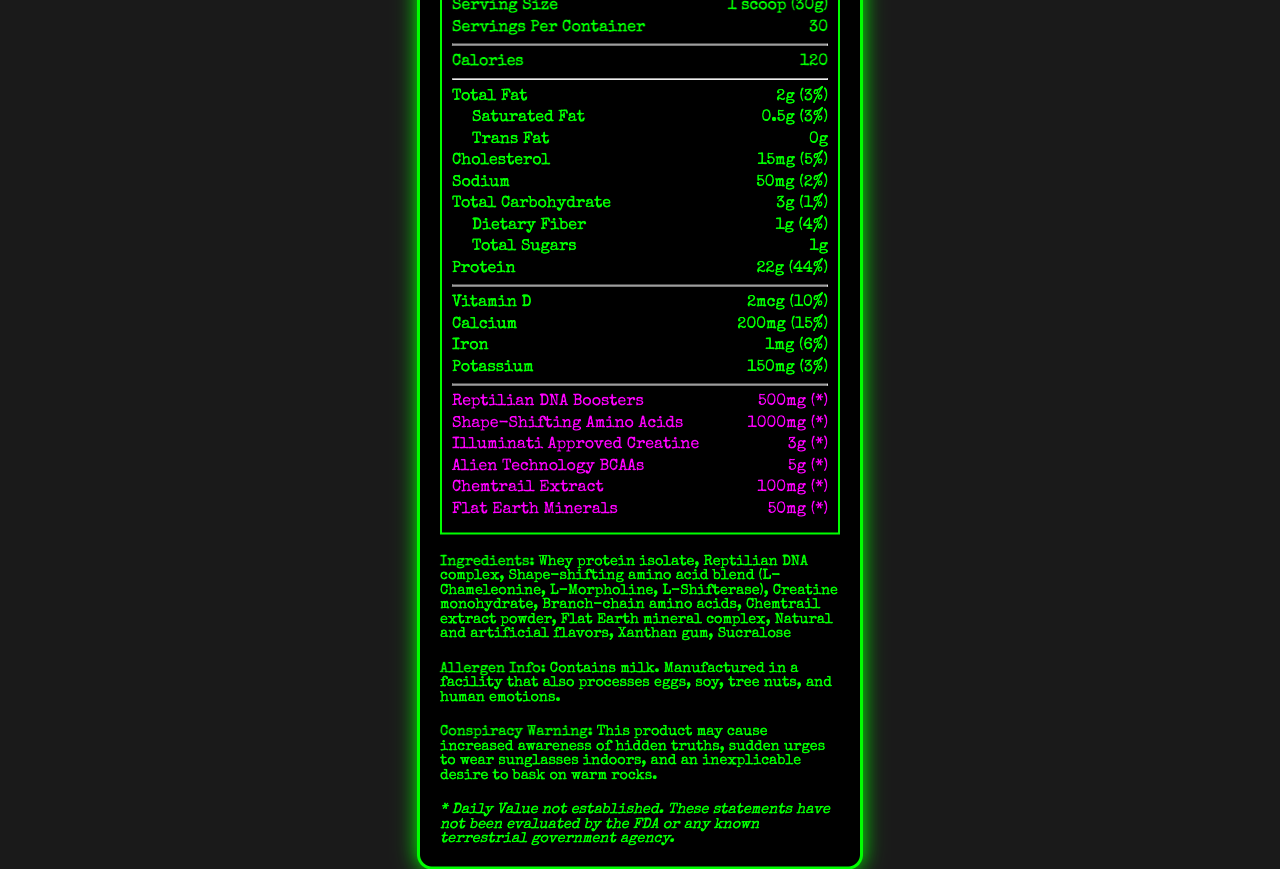what is the serving size? The serving size is clearly mentioned as "1 scoop (30g)" at the top of the document.
Answer: 1 scoop (30g) how many calories are in one serving? The calorie count per serving is specified at the top of the nutrition label as 120 calories.
Answer: 120 what is the daily value percentage of protein in one serving? Under the protein section, the document lists 22g of protein with a daily value percentage of 44%.
Answer: 44% what is the amount of reptilian DNA boosters per serving? The amount of reptilian DNA boosters is listed as 500mg in the conspiracy items section.
Answer: 500mg list the vitamins and minerals in this product The vitamins and minerals are Vitamin D, Calcium, Iron, and Potassium as listed under their respective amounts and daily values.
Answer: Vitamin D, Calcium, Iron, Potassium how much total fat does one serving contain? The document specifies 2g of total fat with a daily value of 3% in the nutrition label.
Answer: 2g (3%) Is trans fat included in the nutritive content? A. Yes B. No C. Not mentioned The document clearly states "Trans Fat: 0g" under the nutrition facts.
Answer: B how many servings are there per container? The number of servings per container is listed as 30 at the top of the document.
Answer: 30 which of the following is an ingredient in the Lizard People Protein Shake? A. High fructose corn syrup B. Whey protein isolate C. Palm oil D. Soy protein isolate The ingredients list includes "Whey protein isolate."
Answer: B Does this product contain any sugars? The document specifies that the product contains 1g of total sugars per serving.
Answer: Yes What is the main idea of this document? The document includes the product name, serving size, servings per container, calories, detailed nutritional information, unique additives, ingredients, allergen information, a conspiracy warning, and a disclaimer.
Answer: This document provides detailed nutrition facts and ingredient information about the "Lizard People Protein Shake," highlighting both traditional nutrients and unique, conspiracy-themed additives. Can this product cause an increased awareness of hidden truths? The conspiracy warning specifically mentions that the product may cause increased awareness of hidden truths.
Answer: Yes What does the allergen information indicate? The allergen information states that the product contains milk and is manufactured in a facility that processes eggs, soy, tree nuts, and human emotions.
Answer: Contains milk. Manufactured in a facility that also processes eggs, soy, tree nuts, and human emotions. Does the document provide enough information to verify the benefits of reptilian DNA boosters? The document lists reptilian DNA boosters with an asterisk indicating "Daily Value not established" and doesn't provide enough information to verify their benefits.
Answer: Not enough information 